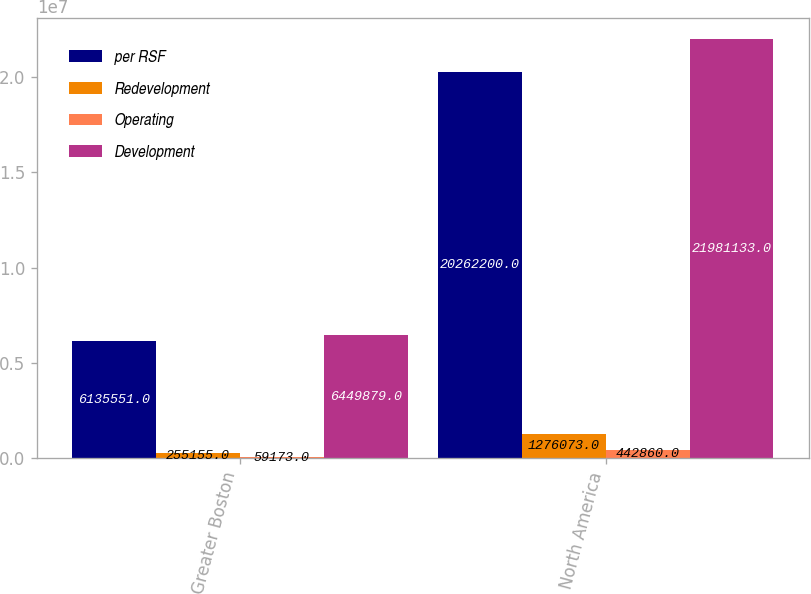Convert chart to OTSL. <chart><loc_0><loc_0><loc_500><loc_500><stacked_bar_chart><ecel><fcel>Greater Boston<fcel>North America<nl><fcel>per RSF<fcel>6.13555e+06<fcel>2.02622e+07<nl><fcel>Redevelopment<fcel>255155<fcel>1.27607e+06<nl><fcel>Operating<fcel>59173<fcel>442860<nl><fcel>Development<fcel>6.44988e+06<fcel>2.19811e+07<nl></chart> 